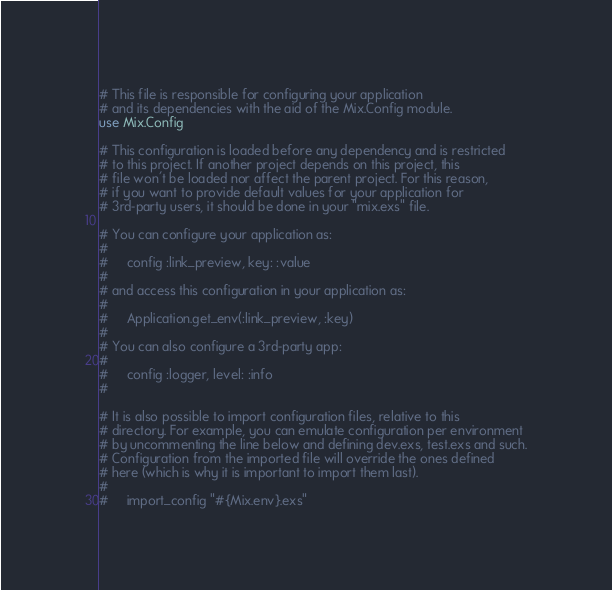<code> <loc_0><loc_0><loc_500><loc_500><_Elixir_># This file is responsible for configuring your application
# and its dependencies with the aid of the Mix.Config module.
use Mix.Config

# This configuration is loaded before any dependency and is restricted
# to this project. If another project depends on this project, this
# file won't be loaded nor affect the parent project. For this reason,
# if you want to provide default values for your application for
# 3rd-party users, it should be done in your "mix.exs" file.

# You can configure your application as:
#
#     config :link_preview, key: :value
#
# and access this configuration in your application as:
#
#     Application.get_env(:link_preview, :key)
#
# You can also configure a 3rd-party app:
#
#     config :logger, level: :info
#

# It is also possible to import configuration files, relative to this
# directory. For example, you can emulate configuration per environment
# by uncommenting the line below and defining dev.exs, test.exs and such.
# Configuration from the imported file will override the ones defined
# here (which is why it is important to import them last).
#
#     import_config "#{Mix.env}.exs"
</code> 